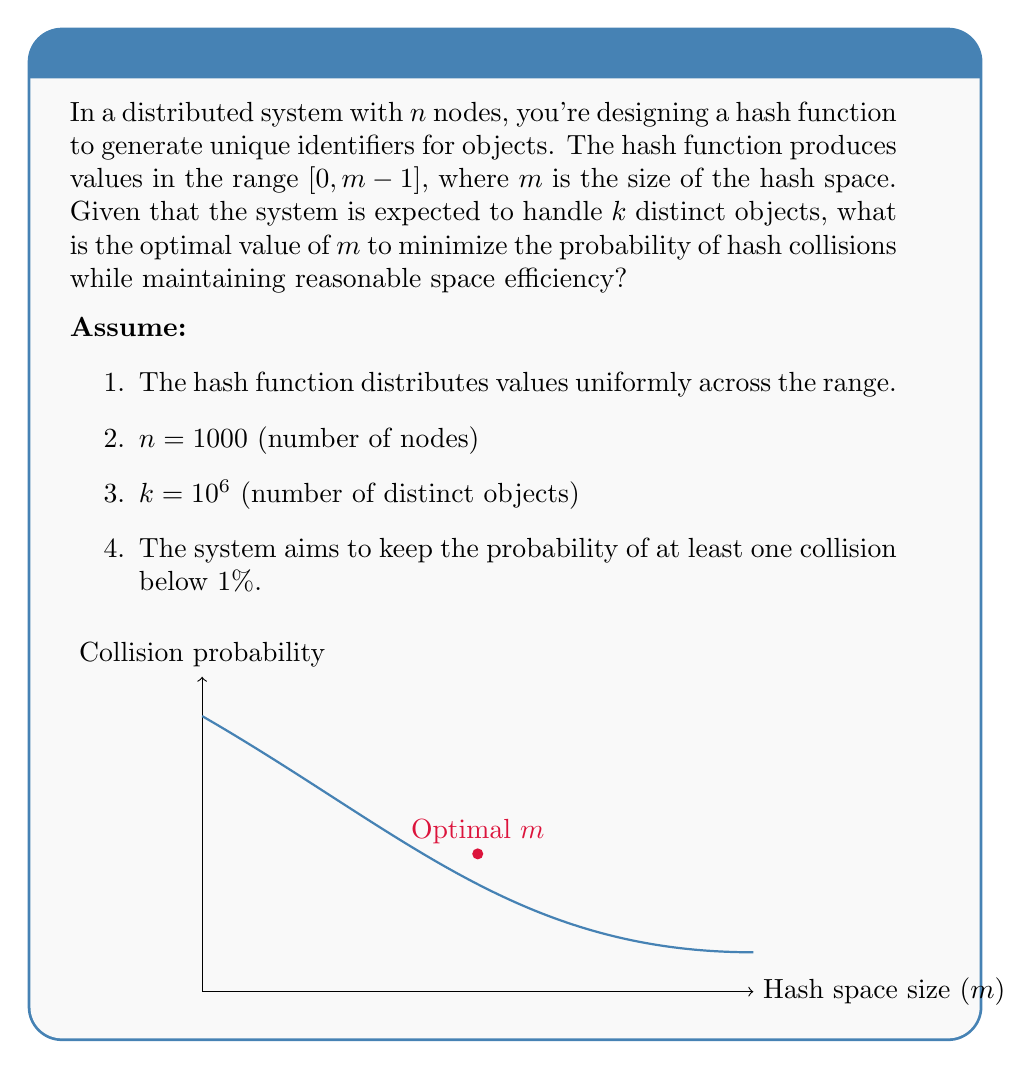Can you solve this math problem? To solve this problem, we'll use the birthday paradox formula and optimize it for our scenario:

1. The probability of at least one collision is given by:
   $$P(\text{at least one collision}) = 1 - P(\text{no collisions})$$

2. The probability of no collisions is:
   $$P(\text{no collisions}) = \frac{m!}{m^k(m-k)!}$$

3. We want to keep this probability below 1%, so:
   $$1 - \frac{m!}{m^k(m-k)!} < 0.01$$

4. For large $m$ and $k$, we can approximate this using the exponential function:
   $$1 - e^{-k(k-1)/(2m)} < 0.01$$

5. Solving for $m$:
   $$e^{-k(k-1)/(2m)} > 0.99$$
   $$-k(k-1)/(2m) > \ln(0.99)$$
   $$m > \frac{-k(k-1)}{2\ln(0.99)}$$

6. Substituting $k = 10^6$:
   $$m > \frac{-(10^6)(10^6-1)}{2\ln(0.99)} \approx 2.30 \times 10^{10}$$

7. To optimize for space efficiency while maintaining the collision probability below 1%, we should choose the smallest $m$ that satisfies this inequality.

8. Rounding up to the nearest power of 2 (for efficient implementation), we get:
   $$m = 2^{35} = 34,359,738,368$$

This value of $m$ ensures that the probability of collisions remains below 1% while using the smallest possible hash space size.
Answer: $m = 2^{35} = 34,359,738,368$ 